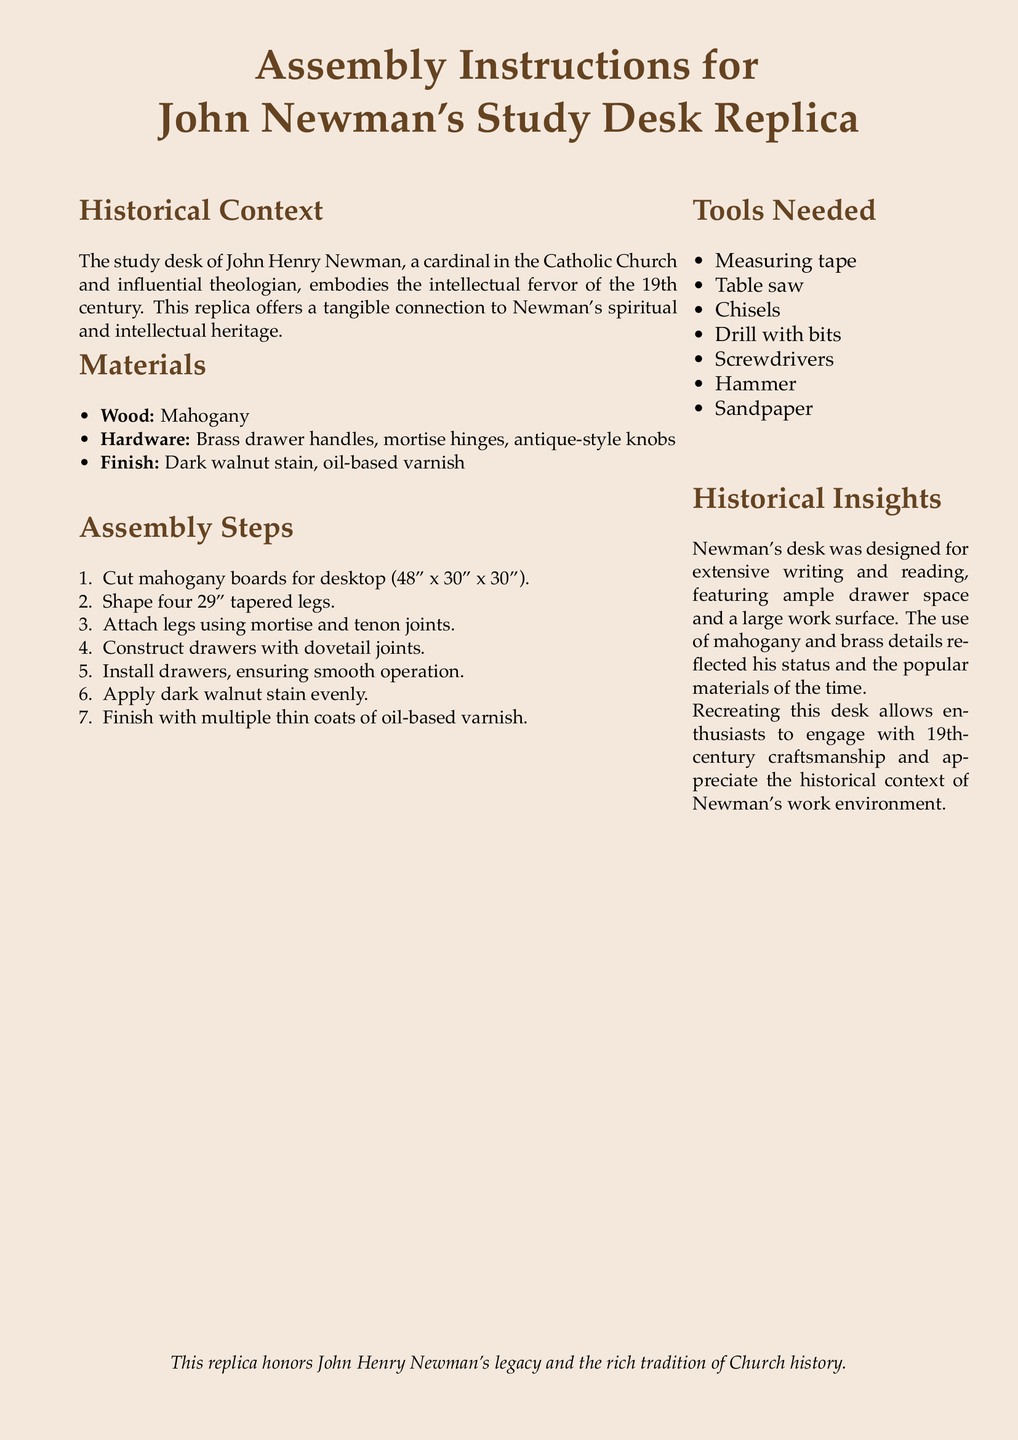What type of wood is specified for the desk? The document states that mahogany is the type of wood used for the desk.
Answer: Mahogany What is the size of the desktop? The document specifies the dimensions of the desktop as 48" x 30".
Answer: 48" x 30" How many tapered legs are to be shaped? The assembly instructions mention that four tapered legs need to be shaped.
Answer: Four What kind of joints are used for the drawers? The document indicates that dovetail joints are to be used for constructing the drawers.
Answer: Dovetail joints What is the finish applied to the desk? The instructions specify a dark walnut stain and oil-based varnish as the finish for the desk.
Answer: Dark walnut stain, oil-based varnish Why was Newman's desk designed this way? The historical insights explain that the desk was designed for extensive writing and reading.
Answer: Extensive writing and reading What tools are needed for assembly? The document lists several tools, including measuring tape, chisels, and a drill, needed for the assembly.
Answer: Measuring tape, chisels, drill What is the main purpose of creating this replica? The document states that recreating the desk allows enthusiasts to engage with 19th-century craftsmanship.
Answer: Engage with 19th-century craftsmanship Who was John Henry Newman? The historical context describes Newman as a cardinal in the Catholic Church and an influential theologian.
Answer: Cardinal and influential theologian 